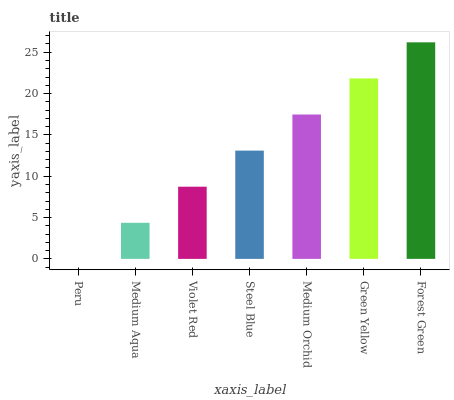Is Peru the minimum?
Answer yes or no. Yes. Is Forest Green the maximum?
Answer yes or no. Yes. Is Medium Aqua the minimum?
Answer yes or no. No. Is Medium Aqua the maximum?
Answer yes or no. No. Is Medium Aqua greater than Peru?
Answer yes or no. Yes. Is Peru less than Medium Aqua?
Answer yes or no. Yes. Is Peru greater than Medium Aqua?
Answer yes or no. No. Is Medium Aqua less than Peru?
Answer yes or no. No. Is Steel Blue the high median?
Answer yes or no. Yes. Is Steel Blue the low median?
Answer yes or no. Yes. Is Medium Orchid the high median?
Answer yes or no. No. Is Forest Green the low median?
Answer yes or no. No. 